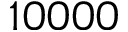Convert formula to latex. <formula><loc_0><loc_0><loc_500><loc_500>1 0 0 0 0</formula> 